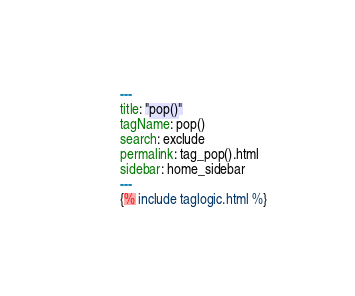Convert code to text. <code><loc_0><loc_0><loc_500><loc_500><_YAML_>---
title: "pop()"
tagName: pop()
search: exclude
permalink: tag_pop().html
sidebar: home_sidebar
---
{% include taglogic.html %}
</code> 